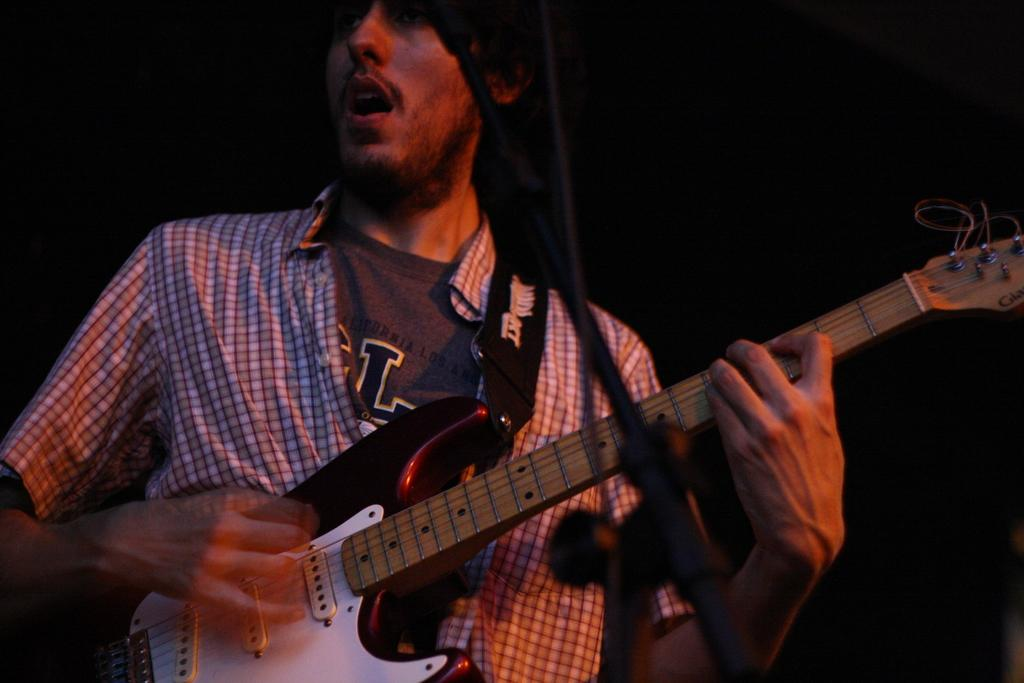What is the man in the image doing? The man is singing on a microphone. What instrument is the man is holding in the image? The man is holding a guitar. What type of beds can be seen in the background of the image? There are no beds present in the image. 